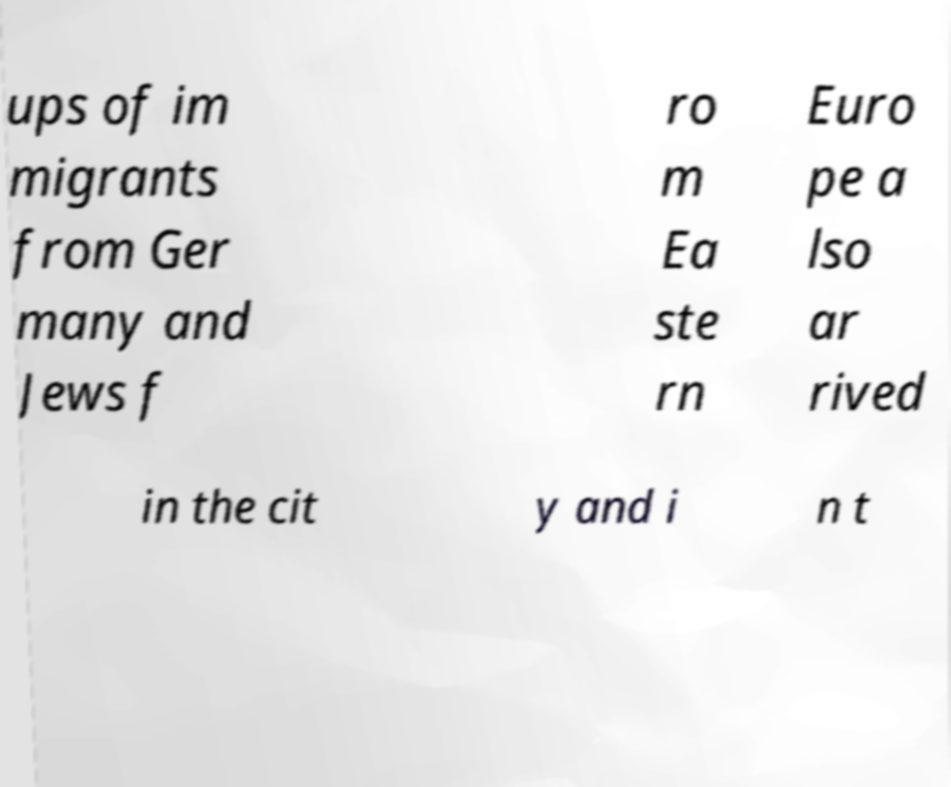Can you read and provide the text displayed in the image?This photo seems to have some interesting text. Can you extract and type it out for me? ups of im migrants from Ger many and Jews f ro m Ea ste rn Euro pe a lso ar rived in the cit y and i n t 